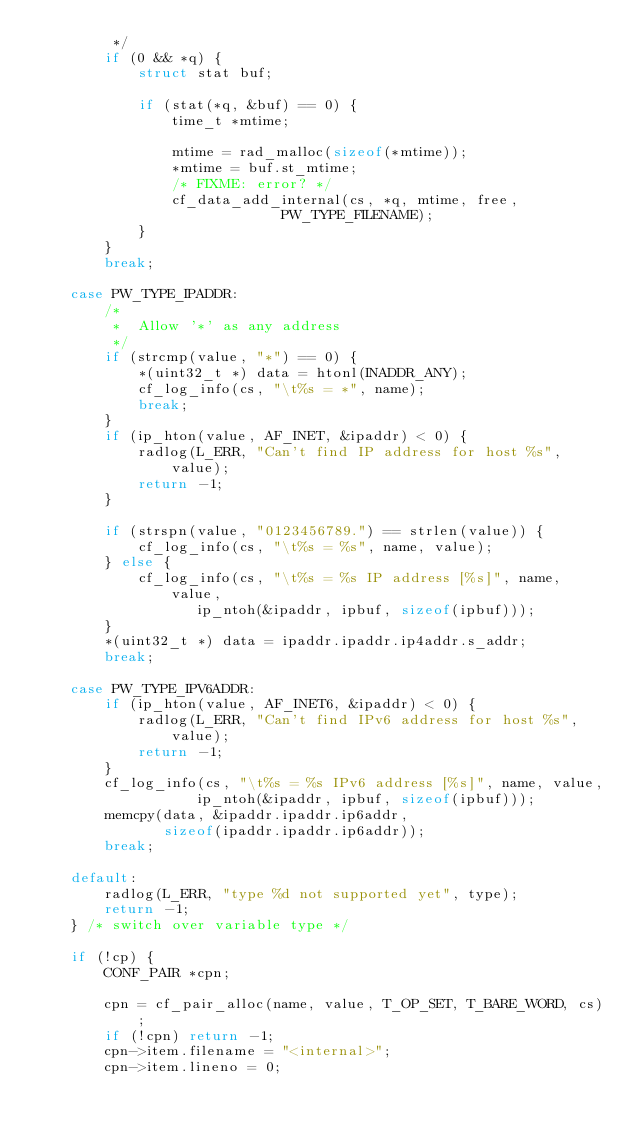<code> <loc_0><loc_0><loc_500><loc_500><_C_>		 */
		if (0 && *q) {
			struct stat buf;

			if (stat(*q, &buf) == 0) {
				time_t *mtime;

				mtime = rad_malloc(sizeof(*mtime));
				*mtime = buf.st_mtime;
				/* FIXME: error? */
				cf_data_add_internal(cs, *q, mtime, free,
						     PW_TYPE_FILENAME);
			}
		}
		break;

	case PW_TYPE_IPADDR:
		/*
		 *	Allow '*' as any address
		 */
		if (strcmp(value, "*") == 0) {
			*(uint32_t *) data = htonl(INADDR_ANY);
			cf_log_info(cs, "\t%s = *", name);
			break;
		}
		if (ip_hton(value, AF_INET, &ipaddr) < 0) {
			radlog(L_ERR, "Can't find IP address for host %s", value);
			return -1;
		}
		
		if (strspn(value, "0123456789.") == strlen(value)) {
			cf_log_info(cs, "\t%s = %s", name, value);
		} else {
			cf_log_info(cs, "\t%s = %s IP address [%s]", name, value,
			       ip_ntoh(&ipaddr, ipbuf, sizeof(ipbuf)));
		}
		*(uint32_t *) data = ipaddr.ipaddr.ip4addr.s_addr;
		break;

	case PW_TYPE_IPV6ADDR:
		if (ip_hton(value, AF_INET6, &ipaddr) < 0) {
			radlog(L_ERR, "Can't find IPv6 address for host %s", value);
			return -1;
		}
		cf_log_info(cs, "\t%s = %s IPv6 address [%s]", name, value,
			       ip_ntoh(&ipaddr, ipbuf, sizeof(ipbuf)));
		memcpy(data, &ipaddr.ipaddr.ip6addr,
		       sizeof(ipaddr.ipaddr.ip6addr));
		break;

	default:
		radlog(L_ERR, "type %d not supported yet", type);
		return -1;
	} /* switch over variable type */

	if (!cp) {
		CONF_PAIR *cpn;

		cpn = cf_pair_alloc(name, value, T_OP_SET, T_BARE_WORD, cs);
		if (!cpn) return -1;
		cpn->item.filename = "<internal>";
		cpn->item.lineno = 0;</code> 